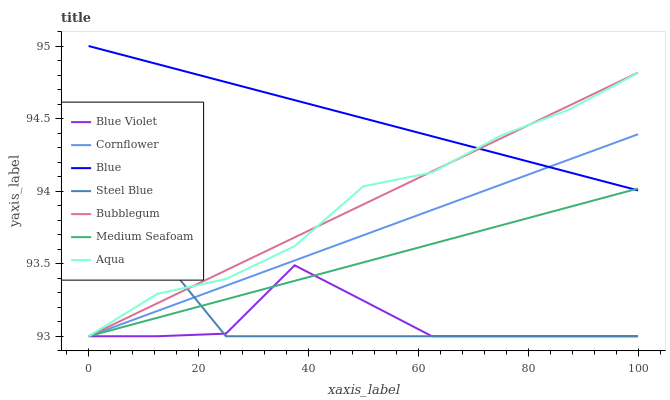Does Blue Violet have the minimum area under the curve?
Answer yes or no. Yes. Does Blue have the maximum area under the curve?
Answer yes or no. Yes. Does Cornflower have the minimum area under the curve?
Answer yes or no. No. Does Cornflower have the maximum area under the curve?
Answer yes or no. No. Is Medium Seafoam the smoothest?
Answer yes or no. Yes. Is Blue Violet the roughest?
Answer yes or no. Yes. Is Cornflower the smoothest?
Answer yes or no. No. Is Cornflower the roughest?
Answer yes or no. No. Does Cornflower have the lowest value?
Answer yes or no. Yes. Does Blue have the highest value?
Answer yes or no. Yes. Does Cornflower have the highest value?
Answer yes or no. No. Is Steel Blue less than Blue?
Answer yes or no. Yes. Is Blue greater than Steel Blue?
Answer yes or no. Yes. Does Blue Violet intersect Cornflower?
Answer yes or no. Yes. Is Blue Violet less than Cornflower?
Answer yes or no. No. Is Blue Violet greater than Cornflower?
Answer yes or no. No. Does Steel Blue intersect Blue?
Answer yes or no. No. 